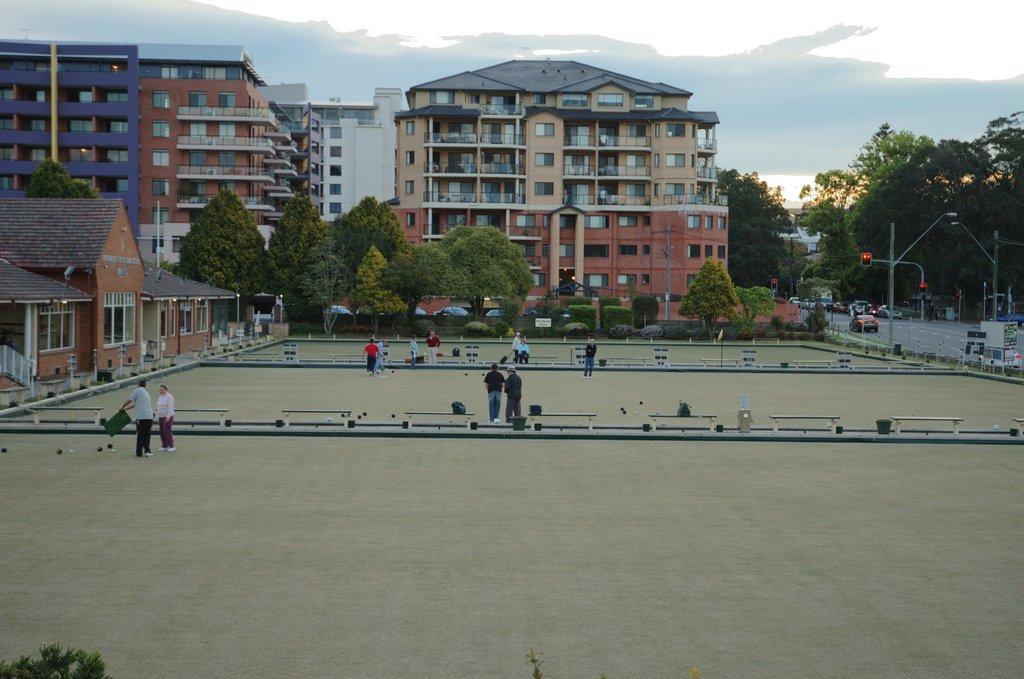In one or two sentences, can you explain what this image depicts? There are people and other objects are present on the ground as we can see in the middle of this image. We can see trees, buildings and poles in the background and the sky is at the top of this image. 